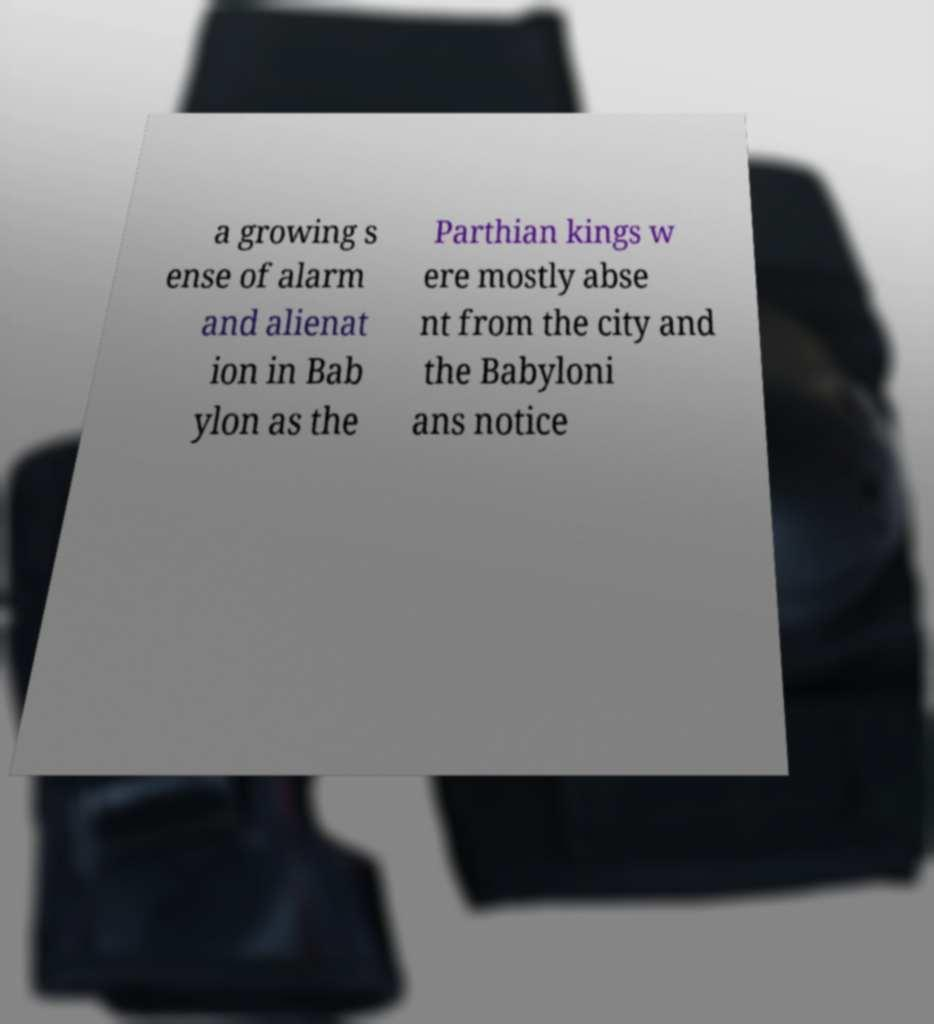Could you extract and type out the text from this image? a growing s ense of alarm and alienat ion in Bab ylon as the Parthian kings w ere mostly abse nt from the city and the Babyloni ans notice 